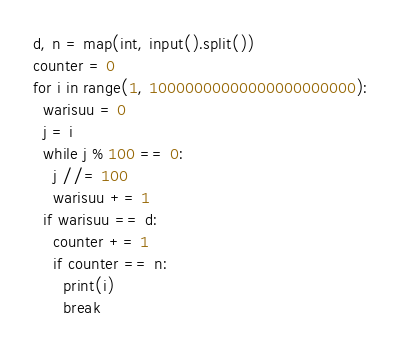Convert code to text. <code><loc_0><loc_0><loc_500><loc_500><_Python_>d, n = map(int, input().split())
counter = 0
for i in range(1, 10000000000000000000000):
  warisuu = 0
  j = i
  while j % 100 == 0:
    j //= 100
    warisuu += 1
  if warisuu == d:
    counter += 1
    if counter == n:
      print(i)
      break
</code> 